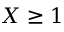Convert formula to latex. <formula><loc_0><loc_0><loc_500><loc_500>X \geq 1</formula> 